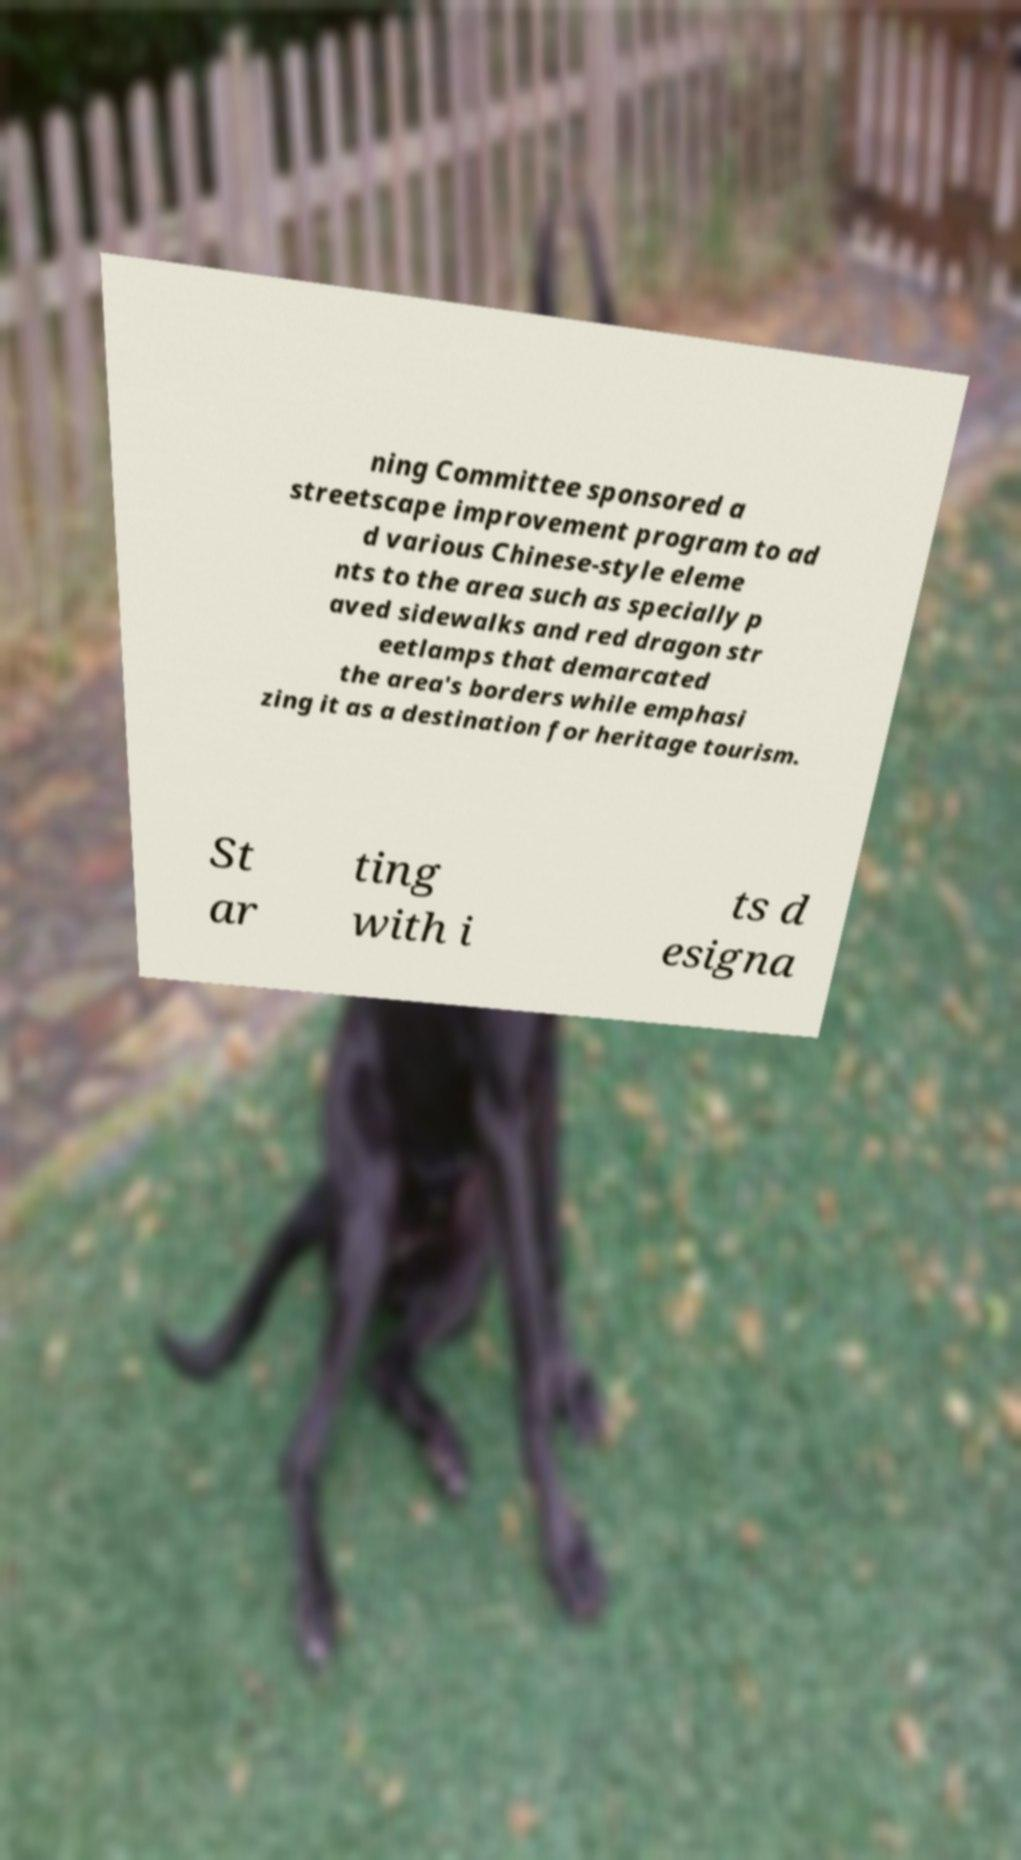Please read and relay the text visible in this image. What does it say? ning Committee sponsored a streetscape improvement program to ad d various Chinese-style eleme nts to the area such as specially p aved sidewalks and red dragon str eetlamps that demarcated the area's borders while emphasi zing it as a destination for heritage tourism. St ar ting with i ts d esigna 